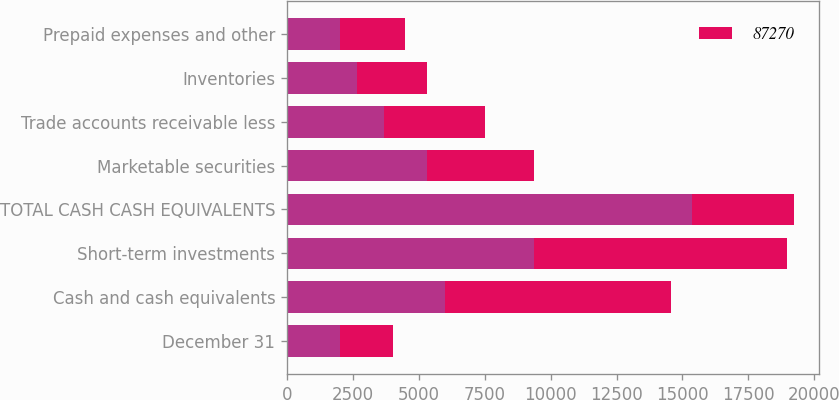Convert chart to OTSL. <chart><loc_0><loc_0><loc_500><loc_500><stacked_bar_chart><ecel><fcel>December 31<fcel>Cash and cash equivalents<fcel>Short-term investments<fcel>TOTAL CASH CASH EQUIVALENTS<fcel>Marketable securities<fcel>Trade accounts receivable less<fcel>Inventories<fcel>Prepaid expenses and other<nl><fcel>nan<fcel>2017<fcel>6006<fcel>9352<fcel>15358<fcel>5317<fcel>3667<fcel>2655<fcel>2000<nl><fcel>87270<fcel>2016<fcel>8555<fcel>9595<fcel>3856<fcel>4051<fcel>3856<fcel>2675<fcel>2481<nl></chart> 